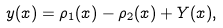Convert formula to latex. <formula><loc_0><loc_0><loc_500><loc_500>y ( x ) = \rho _ { 1 } ( x ) - \rho _ { 2 } ( x ) + Y ( x ) ,</formula> 